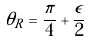Convert formula to latex. <formula><loc_0><loc_0><loc_500><loc_500>\theta _ { R } = \frac { \pi } { 4 } + \frac { \epsilon } { 2 }</formula> 